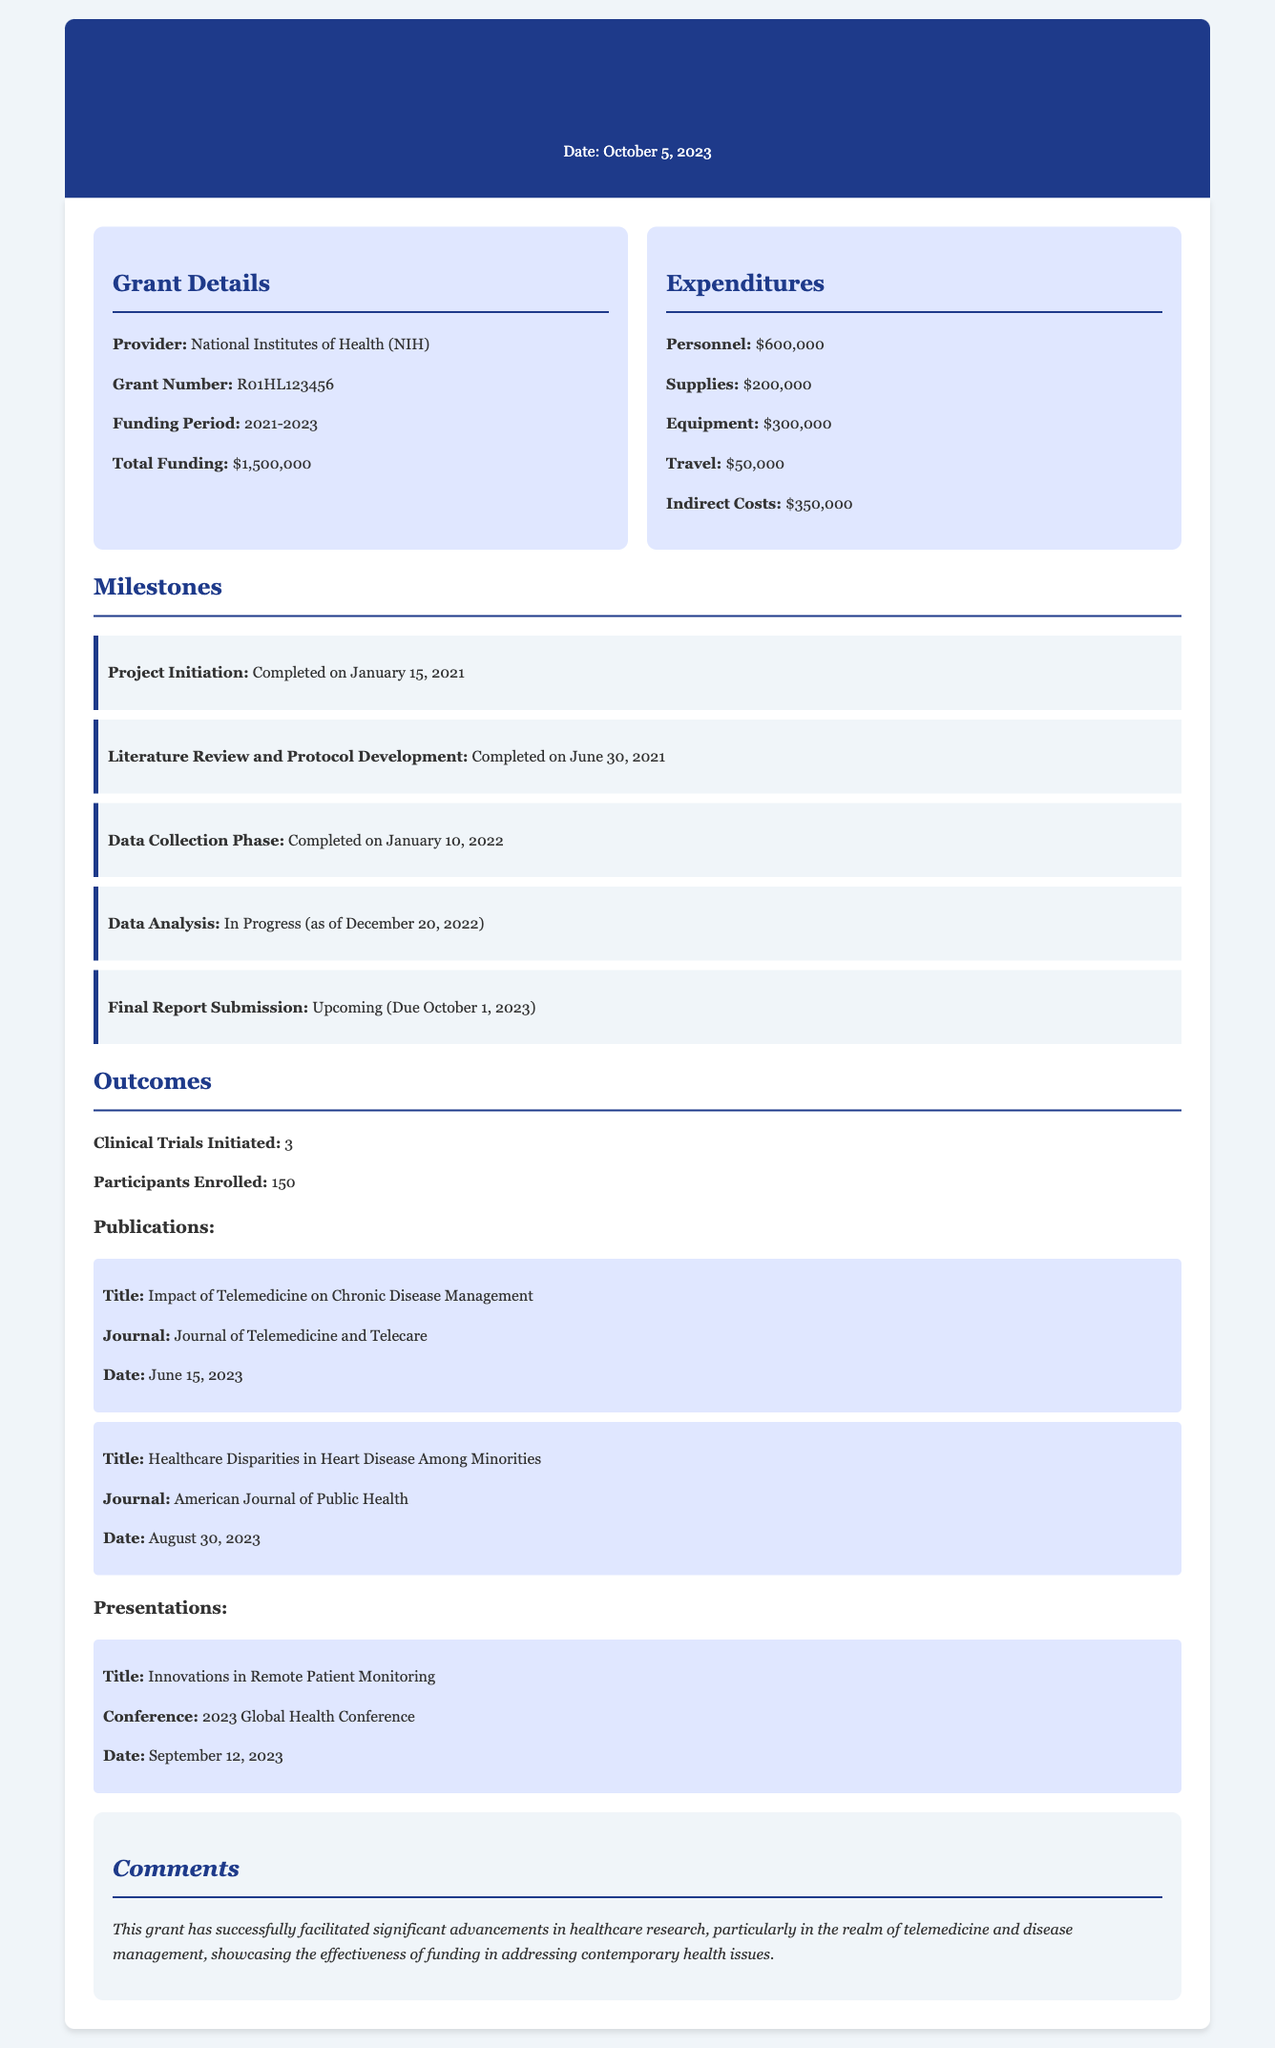What is the grant number? The grant number is explicitly mentioned in the report details section.
Answer: R01HL123456 Who is the provider of the grant? The provider of the grant is specified at the beginning of the report details.
Answer: National Institutes of Health (NIH) What is the total funding amount? The total funding amount is listed under the grant details section.
Answer: $1,500,000 What milestone was completed on January 15, 2021? This milestone gives the specific date and its completion status in the milestones section.
Answer: Project Initiation How many clinical trials were initiated? The number of clinical trials is directly stated in the outcomes section.
Answer: 3 When is the final report submission due? The due date for the final report submission is provided in the milestones section.
Answer: October 1, 2023 Which publication was released on June 15, 2023? The title and date of the publication are listed in the outcomes section.
Answer: Impact of Telemedicine on Chronic Disease Management What is one of the commented advancements of this grant? The comment section highlights the major advancements facilitated by the grant.
Answer: Telemedicine What conference did the presentation take place? The conference details are specified under the presentations section.
Answer: 2023 Global Health Conference 